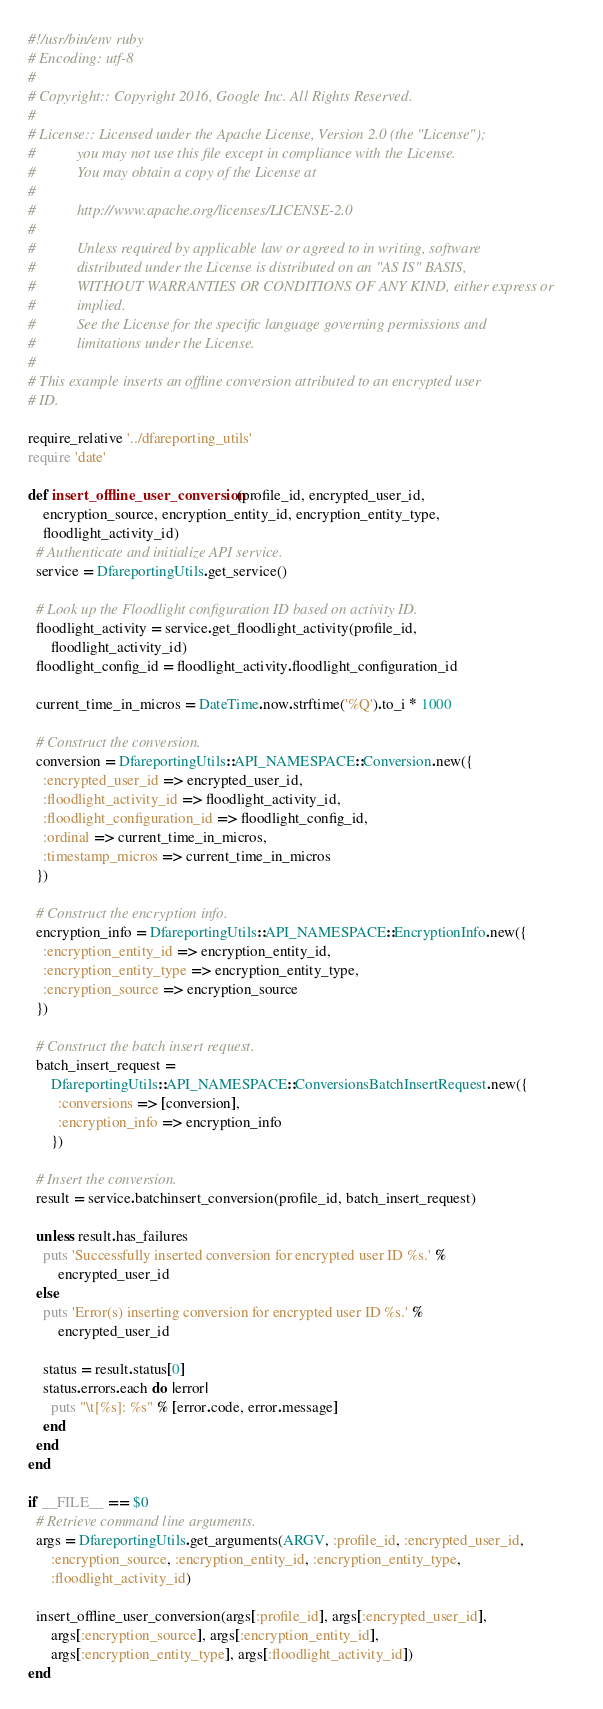Convert code to text. <code><loc_0><loc_0><loc_500><loc_500><_Ruby_>#!/usr/bin/env ruby
# Encoding: utf-8
#
# Copyright:: Copyright 2016, Google Inc. All Rights Reserved.
#
# License:: Licensed under the Apache License, Version 2.0 (the "License");
#           you may not use this file except in compliance with the License.
#           You may obtain a copy of the License at
#
#           http://www.apache.org/licenses/LICENSE-2.0
#
#           Unless required by applicable law or agreed to in writing, software
#           distributed under the License is distributed on an "AS IS" BASIS,
#           WITHOUT WARRANTIES OR CONDITIONS OF ANY KIND, either express or
#           implied.
#           See the License for the specific language governing permissions and
#           limitations under the License.
#
# This example inserts an offline conversion attributed to an encrypted user
# ID.

require_relative '../dfareporting_utils'
require 'date'

def insert_offline_user_conversion(profile_id, encrypted_user_id,
    encryption_source, encryption_entity_id, encryption_entity_type,
    floodlight_activity_id)
  # Authenticate and initialize API service.
  service = DfareportingUtils.get_service()

  # Look up the Floodlight configuration ID based on activity ID.
  floodlight_activity = service.get_floodlight_activity(profile_id,
      floodlight_activity_id)
  floodlight_config_id = floodlight_activity.floodlight_configuration_id

  current_time_in_micros = DateTime.now.strftime('%Q').to_i * 1000

  # Construct the conversion.
  conversion = DfareportingUtils::API_NAMESPACE::Conversion.new({
    :encrypted_user_id => encrypted_user_id,
    :floodlight_activity_id => floodlight_activity_id,
    :floodlight_configuration_id => floodlight_config_id,
    :ordinal => current_time_in_micros,
    :timestamp_micros => current_time_in_micros
  })

  # Construct the encryption info.
  encryption_info = DfareportingUtils::API_NAMESPACE::EncryptionInfo.new({
    :encryption_entity_id => encryption_entity_id,
    :encryption_entity_type => encryption_entity_type,
    :encryption_source => encryption_source
  })

  # Construct the batch insert request.
  batch_insert_request =
      DfareportingUtils::API_NAMESPACE::ConversionsBatchInsertRequest.new({
        :conversions => [conversion],
        :encryption_info => encryption_info
      })

  # Insert the conversion.
  result = service.batchinsert_conversion(profile_id, batch_insert_request)

  unless result.has_failures
    puts 'Successfully inserted conversion for encrypted user ID %s.' %
        encrypted_user_id
  else
    puts 'Error(s) inserting conversion for encrypted user ID %s.' %
        encrypted_user_id

    status = result.status[0]
    status.errors.each do |error|
      puts "\t[%s]: %s" % [error.code, error.message]
    end
  end
end

if __FILE__ == $0
  # Retrieve command line arguments.
  args = DfareportingUtils.get_arguments(ARGV, :profile_id, :encrypted_user_id,
      :encryption_source, :encryption_entity_id, :encryption_entity_type,
      :floodlight_activity_id)

  insert_offline_user_conversion(args[:profile_id], args[:encrypted_user_id],
      args[:encryption_source], args[:encryption_entity_id],
      args[:encryption_entity_type], args[:floodlight_activity_id])
end
</code> 